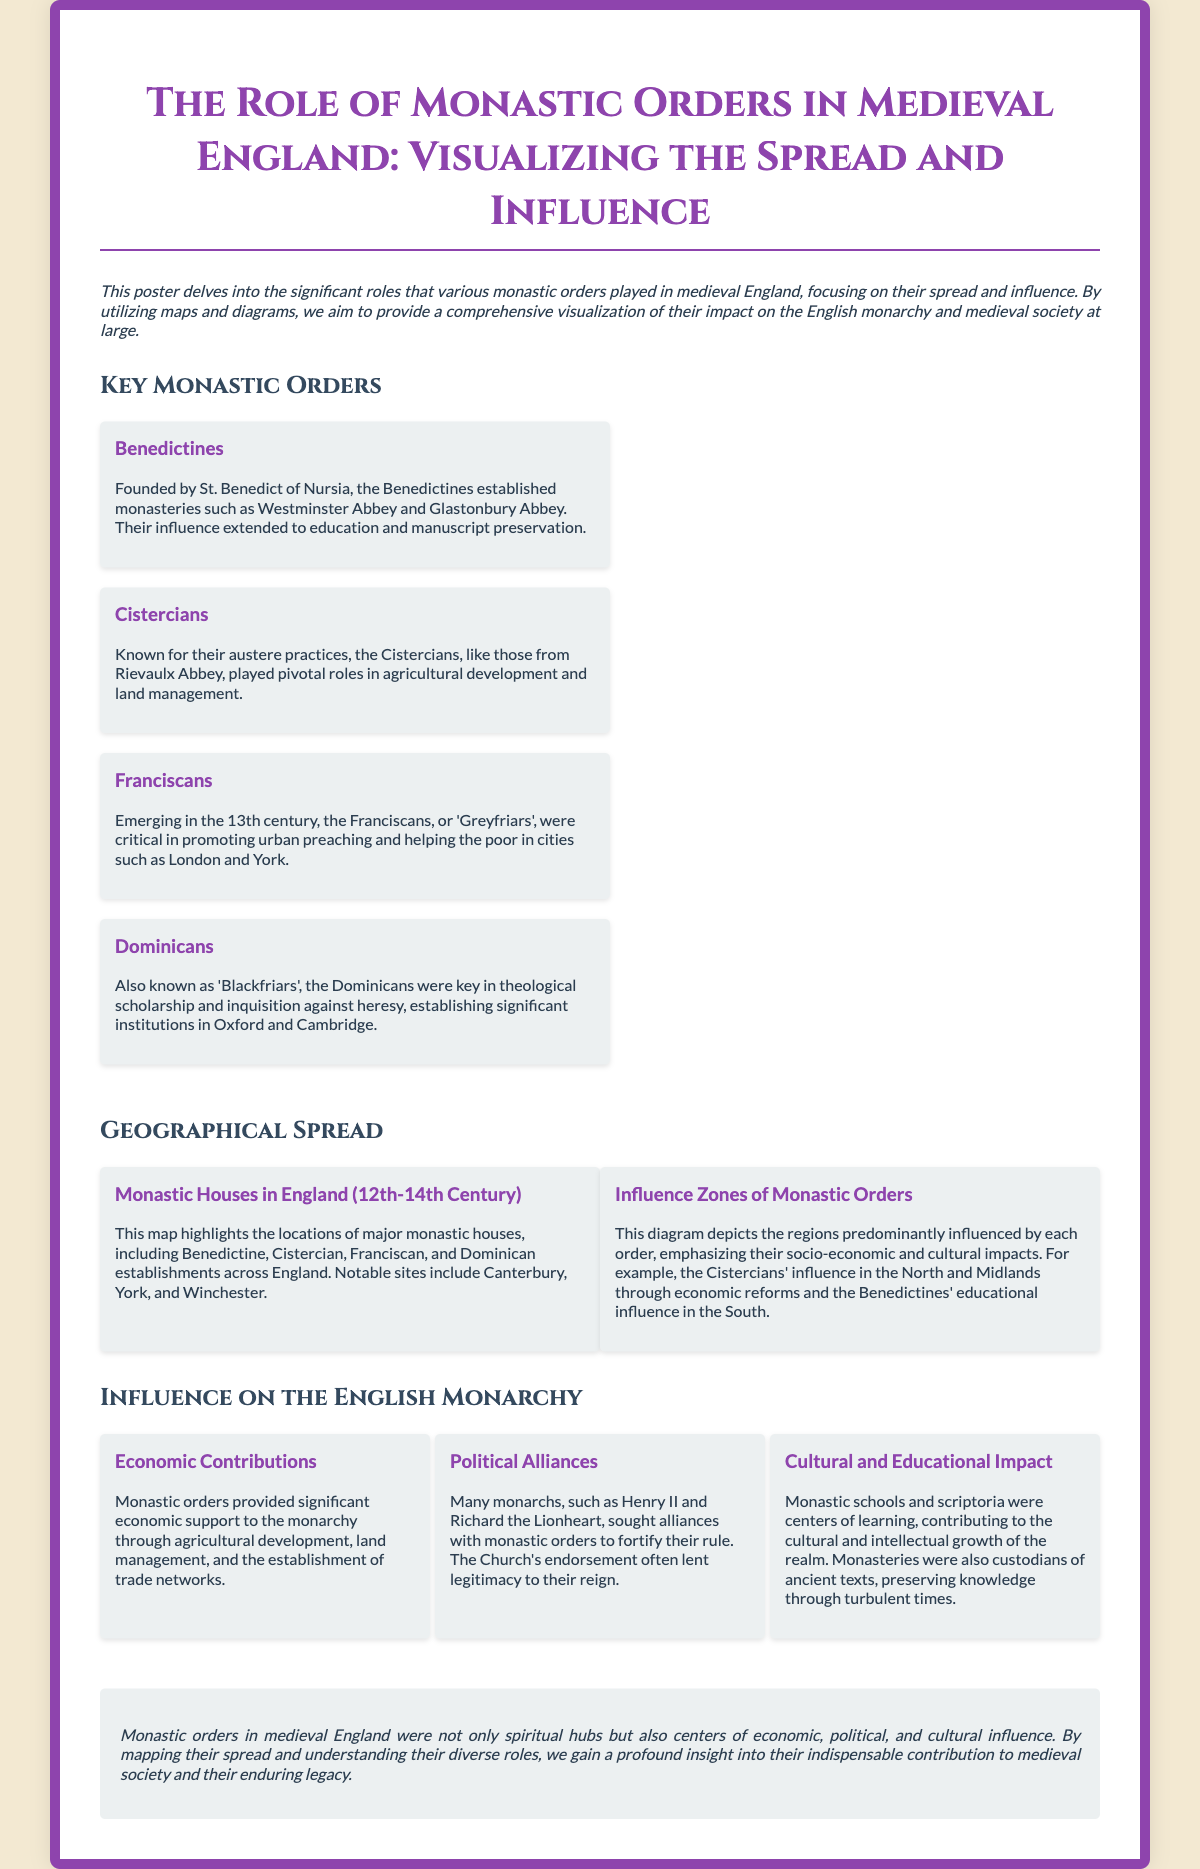What is the title of the poster? The title of the poster is clearly stated at the top and summarizes the focus of the document.
Answer: The Role of Monastic Orders in Medieval England: Visualizing the Spread and Influence Which monastic order is known for its austere practices? The text provides a description of various monastic orders and highlights the characteristics of each.
Answer: Cistercians What location is indicated as a notable site for the Benedictines? The information includes references to specific monasteries associated with the Benedictines.
Answer: Westminster Abbey What form of economic support did monastic orders provide to the monarchy? The document discusses what contributions monastic orders made to the monarchy in terms of their economic activities.
Answer: Agricultural development Which two cities are mentioned in connection with the Franciscans? The interactions mention cities where the Franciscans, or 'Greyfriars', were influential.
Answer: London and York What was a key role of monastic schools? The multi-faceted contributions of monastic orders include their educational efforts, which are described in the document.
Answer: Centers of learning Which monarchs sought alliances with monastic orders? The text specifies examples of monarchs who found support from monastic orders for their reigns.
Answer: Henry II and Richard the Lionheart What type of diagram is presented about monastic influence? The document refers to a specific visual representation that shows geographical influence.
Answer: Influence Zones of Monastic Orders What significant contribution did monasteries make in terms of knowledge? The document describes the intellectual contributions of monastic institutions during medieval times.
Answer: Preserving knowledge 